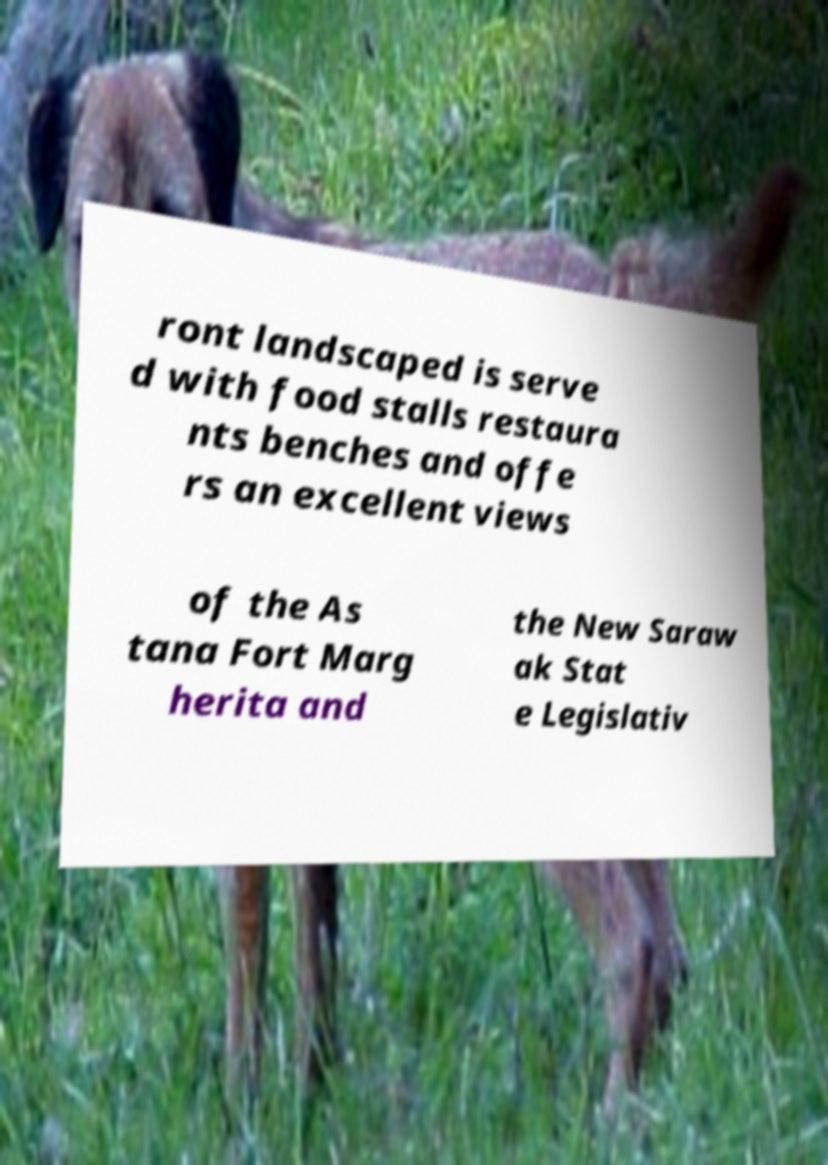What messages or text are displayed in this image? I need them in a readable, typed format. ront landscaped is serve d with food stalls restaura nts benches and offe rs an excellent views of the As tana Fort Marg herita and the New Saraw ak Stat e Legislativ 